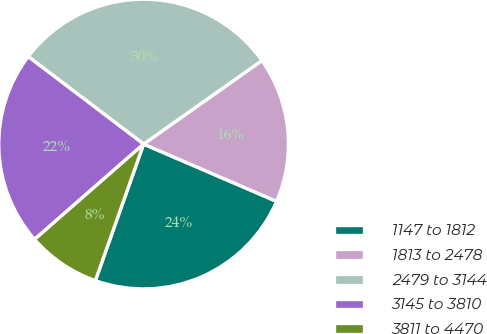<chart> <loc_0><loc_0><loc_500><loc_500><pie_chart><fcel>1147 to 1812<fcel>1813 to 2478<fcel>2479 to 3144<fcel>3145 to 3810<fcel>3811 to 4470<nl><fcel>23.93%<fcel>16.26%<fcel>29.89%<fcel>21.76%<fcel>8.16%<nl></chart> 